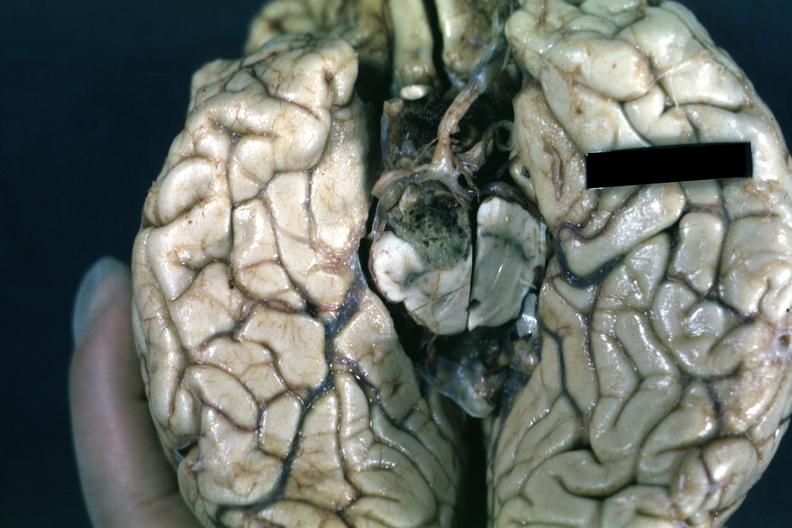does spina bifida show fixed tissue inferior view of cerebral hemisphere with cerebellum and brainstexcised?
Answer the question using a single word or phrase. No 